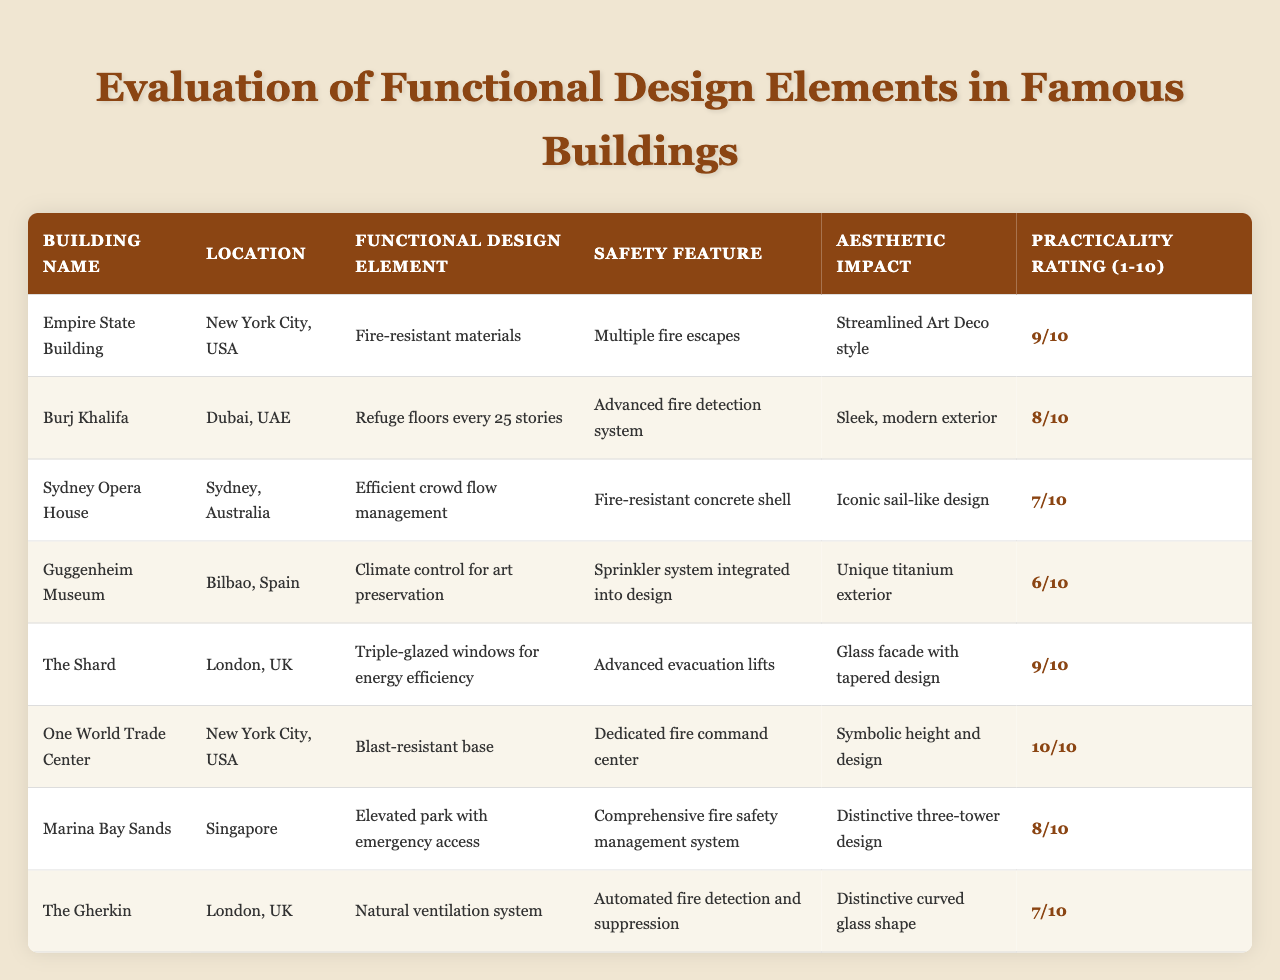What is the practical rating of the Empire State Building? The practical rating for the Empire State Building is listed in the table as 9.
Answer: 9 Which building has the highest practicality rating? By examining the table, One World Trade Center has a practicality rating of 10, which is the highest among all listed buildings.
Answer: One World Trade Center Is the Burj Khalifa's safety feature an advanced fire detection system? According to the table, the Burj Khalifa does indeed have an advanced fire detection system as its safety feature.
Answer: Yes What are the two locations represented in the table with buildings rated 8 or higher? The two buildings rated 8 or higher are Burj Khalifa (Dubai, UAE) and Marina Bay Sands (Singapore), as listed in the table.
Answer: Dubai, UAE and Singapore Who implemented an efficient crowd flow management? The Sydney Opera House is noted for its efficient crowd flow management as the functional design element in the table.
Answer: Sydney Opera House What is the average practicality rating of all the buildings listed? To find the average, sum the practicality ratings (9 + 8 + 7 + 6 + 9 + 10 + 8 + 7 = 64) and divide by the number of buildings (8), resulting in an average of 64/8 = 8.
Answer: 8 Does The Shard focus on energy efficiency with its design? The table indicates that The Shard uses triple-glazed windows for energy efficiency, confirming its focus on this aspect.
Answer: Yes Which building has a unique titanium exterior and what is its practicality rating? The Guggenheim Museum has a unique titanium exterior, and its practicality rating is 6, as shown in the table.
Answer: Guggenheim Museum, 6 What safety feature is explicitly mentioned for One World Trade Center? The table mentions a dedicated fire command center as a safety feature for One World Trade Center.
Answer: Dedicated fire command center Among all listed buildings, which one has the least aesthetic impact rating? The Guggenheim Museum has the least aesthetic impact rating of 6 compared to the other buildings in the table.
Answer: Guggenheim Museum 